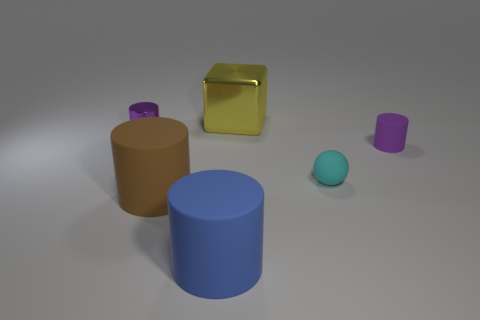There is a thing that is the same color as the tiny matte cylinder; what is its material?
Keep it short and to the point. Metal. Does the small purple shiny object have the same shape as the metal thing right of the brown matte thing?
Provide a succinct answer. No. There is a purple object on the right side of the cyan sphere; is its shape the same as the big yellow object?
Make the answer very short. No. Are there any brown cylinders that are in front of the rubber object that is to the left of the matte cylinder in front of the big brown object?
Offer a terse response. No. There is a cyan matte ball; are there any blue things behind it?
Make the answer very short. No. How many small purple things are to the right of the big brown cylinder on the right side of the purple shiny cylinder?
Keep it short and to the point. 1. There is a yellow thing; is its size the same as the purple thing that is left of the purple matte cylinder?
Keep it short and to the point. No. Are there any matte cylinders that have the same color as the metal cylinder?
Provide a succinct answer. Yes. There is a blue cylinder that is the same material as the large brown thing; what is its size?
Your answer should be very brief. Large. Do the sphere and the big yellow cube have the same material?
Give a very brief answer. No. 